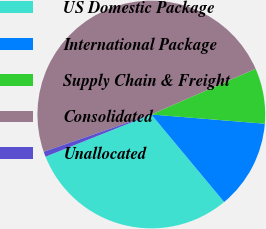Convert chart. <chart><loc_0><loc_0><loc_500><loc_500><pie_chart><fcel>US Domestic Package<fcel>International Package<fcel>Supply Chain & Freight<fcel>Consolidated<fcel>Unallocated<nl><fcel>30.01%<fcel>12.66%<fcel>7.86%<fcel>48.74%<fcel>0.73%<nl></chart> 